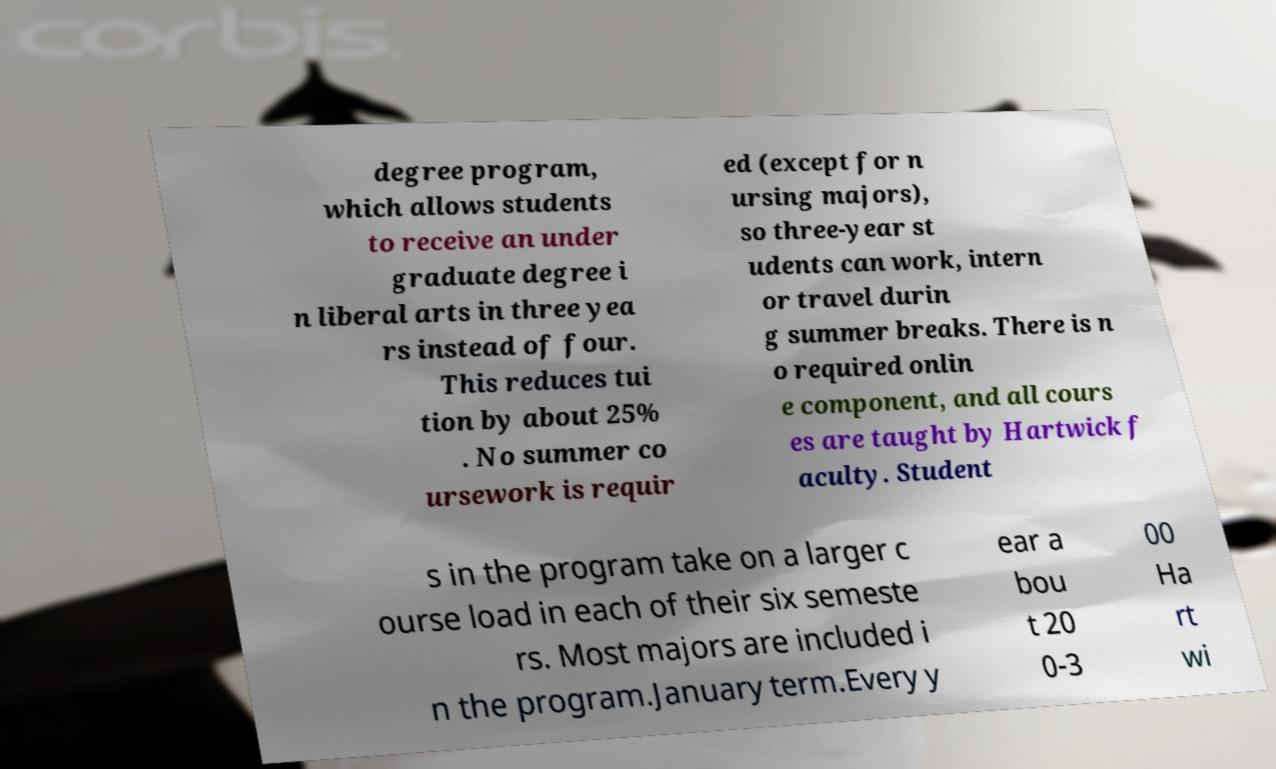What messages or text are displayed in this image? I need them in a readable, typed format. degree program, which allows students to receive an under graduate degree i n liberal arts in three yea rs instead of four. This reduces tui tion by about 25% . No summer co ursework is requir ed (except for n ursing majors), so three-year st udents can work, intern or travel durin g summer breaks. There is n o required onlin e component, and all cours es are taught by Hartwick f aculty. Student s in the program take on a larger c ourse load in each of their six semeste rs. Most majors are included i n the program.January term.Every y ear a bou t 20 0-3 00 Ha rt wi 